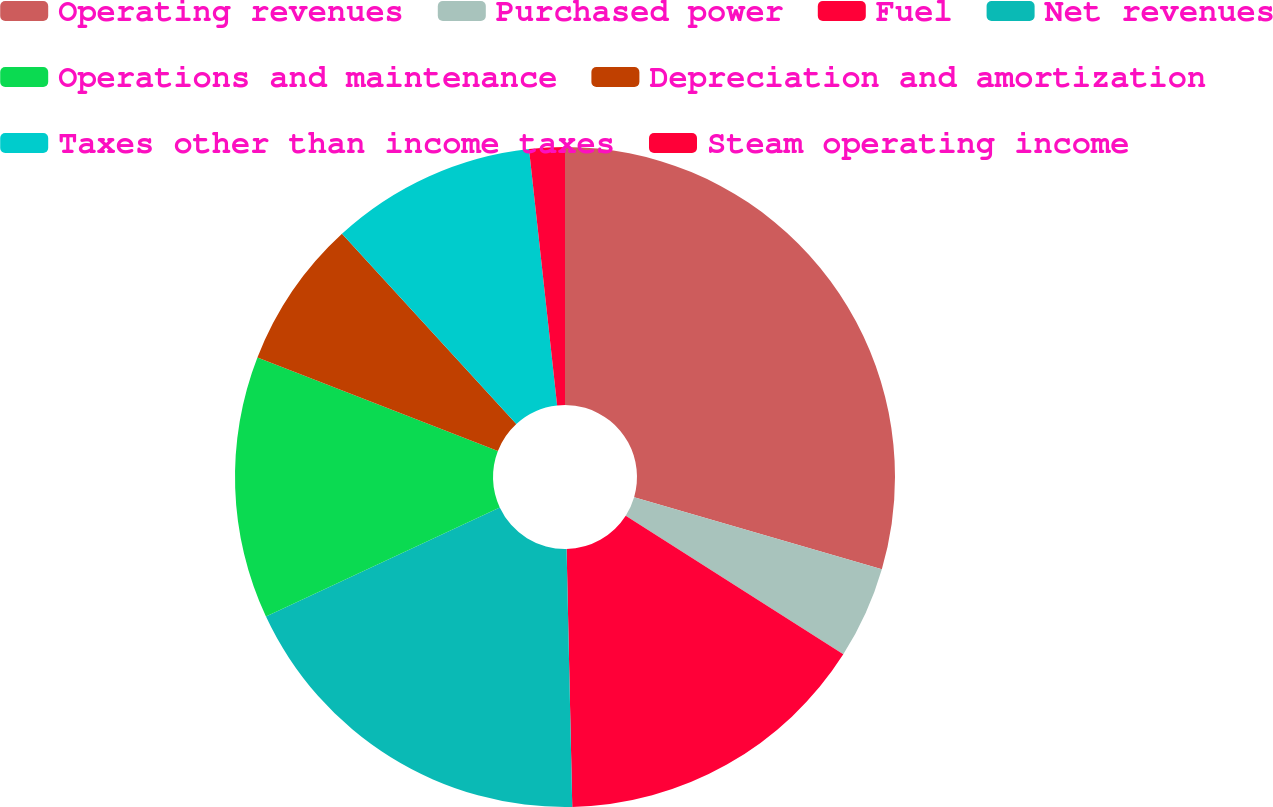<chart> <loc_0><loc_0><loc_500><loc_500><pie_chart><fcel>Operating revenues<fcel>Purchased power<fcel>Fuel<fcel>Net revenues<fcel>Operations and maintenance<fcel>Depreciation and amortization<fcel>Taxes other than income taxes<fcel>Steam operating income<nl><fcel>29.51%<fcel>4.52%<fcel>15.62%<fcel>18.4%<fcel>12.85%<fcel>7.29%<fcel>10.07%<fcel>1.74%<nl></chart> 